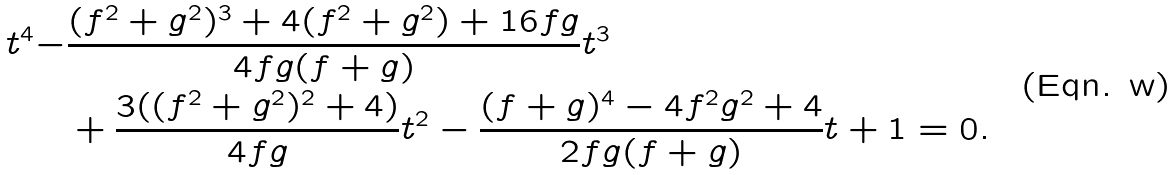Convert formula to latex. <formula><loc_0><loc_0><loc_500><loc_500>t ^ { 4 } - & \frac { ( f ^ { 2 } + g ^ { 2 } ) ^ { 3 } + 4 ( f ^ { 2 } + g ^ { 2 } ) + 1 6 f g } { 4 f g ( f + g ) } t ^ { 3 } \\ & + \frac { 3 ( ( f ^ { 2 } + g ^ { 2 } ) ^ { 2 } + 4 ) } { 4 f g } t ^ { 2 } - \frac { ( f + g ) ^ { 4 } - 4 f ^ { 2 } g ^ { 2 } + 4 } { 2 f g ( f + g ) } t + 1 = 0 .</formula> 